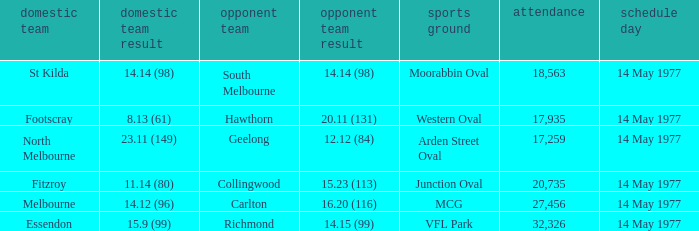I want to know the home team score of the away team of richmond that has a crowd more than 20,735 15.9 (99). Help me parse the entirety of this table. {'header': ['domestic team', 'domestic team result', 'opponent team', 'opponent team result', 'sports ground', 'attendance', 'schedule day'], 'rows': [['St Kilda', '14.14 (98)', 'South Melbourne', '14.14 (98)', 'Moorabbin Oval', '18,563', '14 May 1977'], ['Footscray', '8.13 (61)', 'Hawthorn', '20.11 (131)', 'Western Oval', '17,935', '14 May 1977'], ['North Melbourne', '23.11 (149)', 'Geelong', '12.12 (84)', 'Arden Street Oval', '17,259', '14 May 1977'], ['Fitzroy', '11.14 (80)', 'Collingwood', '15.23 (113)', 'Junction Oval', '20,735', '14 May 1977'], ['Melbourne', '14.12 (96)', 'Carlton', '16.20 (116)', 'MCG', '27,456', '14 May 1977'], ['Essendon', '15.9 (99)', 'Richmond', '14.15 (99)', 'VFL Park', '32,326', '14 May 1977']]} 